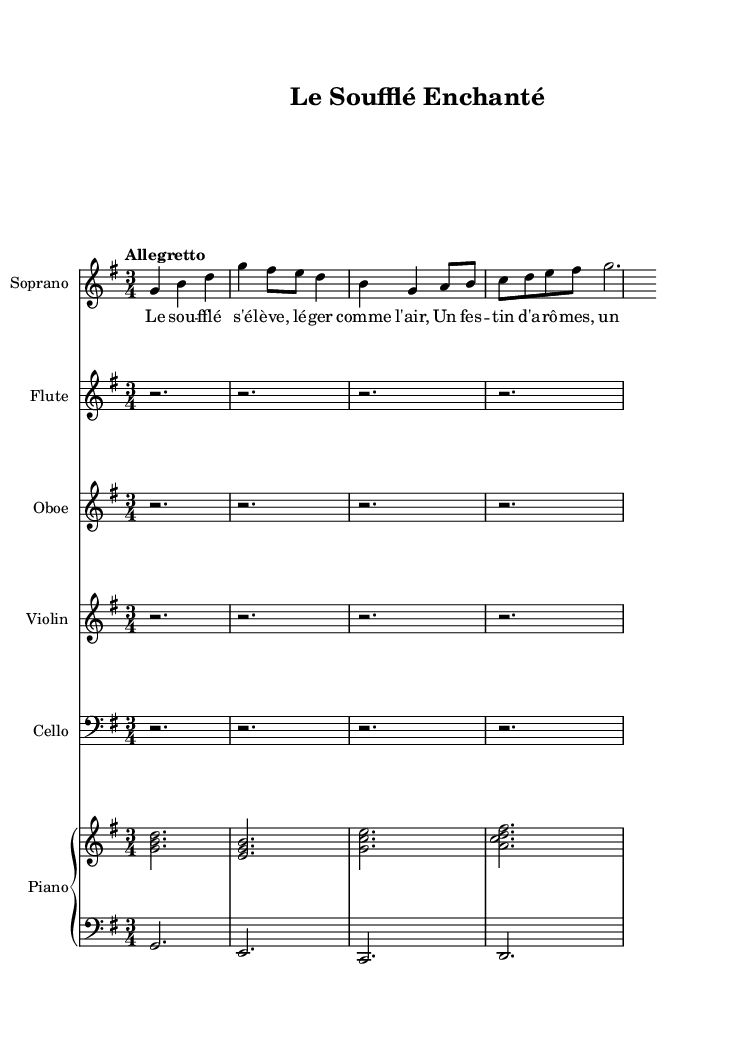What is the key signature of this music? The key signature is G major, which has one sharp (F#). This can be determined by looking at the key signature indicator at the beginning of the score.
Answer: G major What is the time signature of this piece? The time signature is 3/4, indicated at the beginning of the score. This shows that there are three beats per measure, and the quarter note gets one beat.
Answer: 3/4 What is the tempo marking for this operetta? The tempo marking is "Allegretto", which suggests a moderate pace that is quicker than "Andante". This is also visible at the start of the score where tempo is noted.
Answer: Allegretto How many measures are present in the soprano part? The soprano part contains four measures, which can be counted by looking at the bar lines in the specific staff for the soprano.
Answer: 4 In what context does the phrase "Le soufflé s'élève" appear? The phrase "Le soufflé s'élève" is the beginning of the lyrics sung by the soprano, indicating a culinary theme as it relates to the operetta's whimsical nature. This can be confirmed by looking at the lyrics associated with the soprano part.
Answer: Culinary theme What is the instrumentation for this score? The instrumentation for this operetta includes Soprano, Flute, Oboe, Violin, Cello, and Piano. This can be identified at the beginning of each respective staff in the score.
Answer: Soprano, Flute, Oboe, Violin, Cello, Piano 